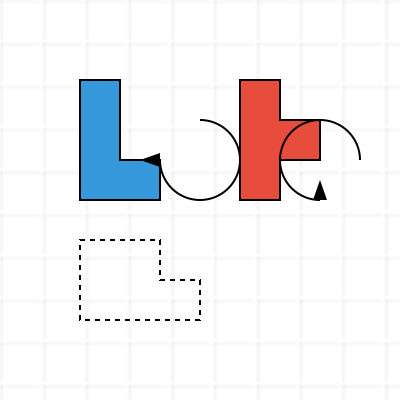As a digital artist working with 3D modeling software, you're presented with two geometric shapes (A and B) and a target slot. Which shape, when rotated appropriately, will fit perfectly into the target slot? Consider the rotation and alignment carefully. To solve this problem, we need to analyze both shapes and the target slot, considering rotations:

1. Examine Shape A:
   - It has a rectangular base with dimensions $4 \times 3$ units
   - There's an additional $1 \times 1$ unit square protruding from the top-right

2. Examine Shape B:
   - It has a rectangular base with dimensions $4 \times 3$ units
   - There's an additional $1 \times 1$ unit square protruding from the middle-right

3. Analyze the target slot:
   - It has a rectangular base with dimensions $4 \times 2$ units
   - There's an additional $1 \times 1$ unit square protruding from the top-right

4. Compare Shape A to the target slot:
   - If rotated 90° clockwise, Shape A will match the target slot perfectly
   - The $4 \times 3$ base becomes $3 \times 4$, fitting the $4 \times 2$ slot
   - The protruding square aligns with the slot's protrusion

5. Compare Shape B to the target slot:
   - No rotation of Shape B will make it fit the target slot
   - The protruding square is in the wrong position to match the slot

Therefore, Shape A, when rotated 90° clockwise, will fit perfectly into the target slot.
Answer: Shape A 